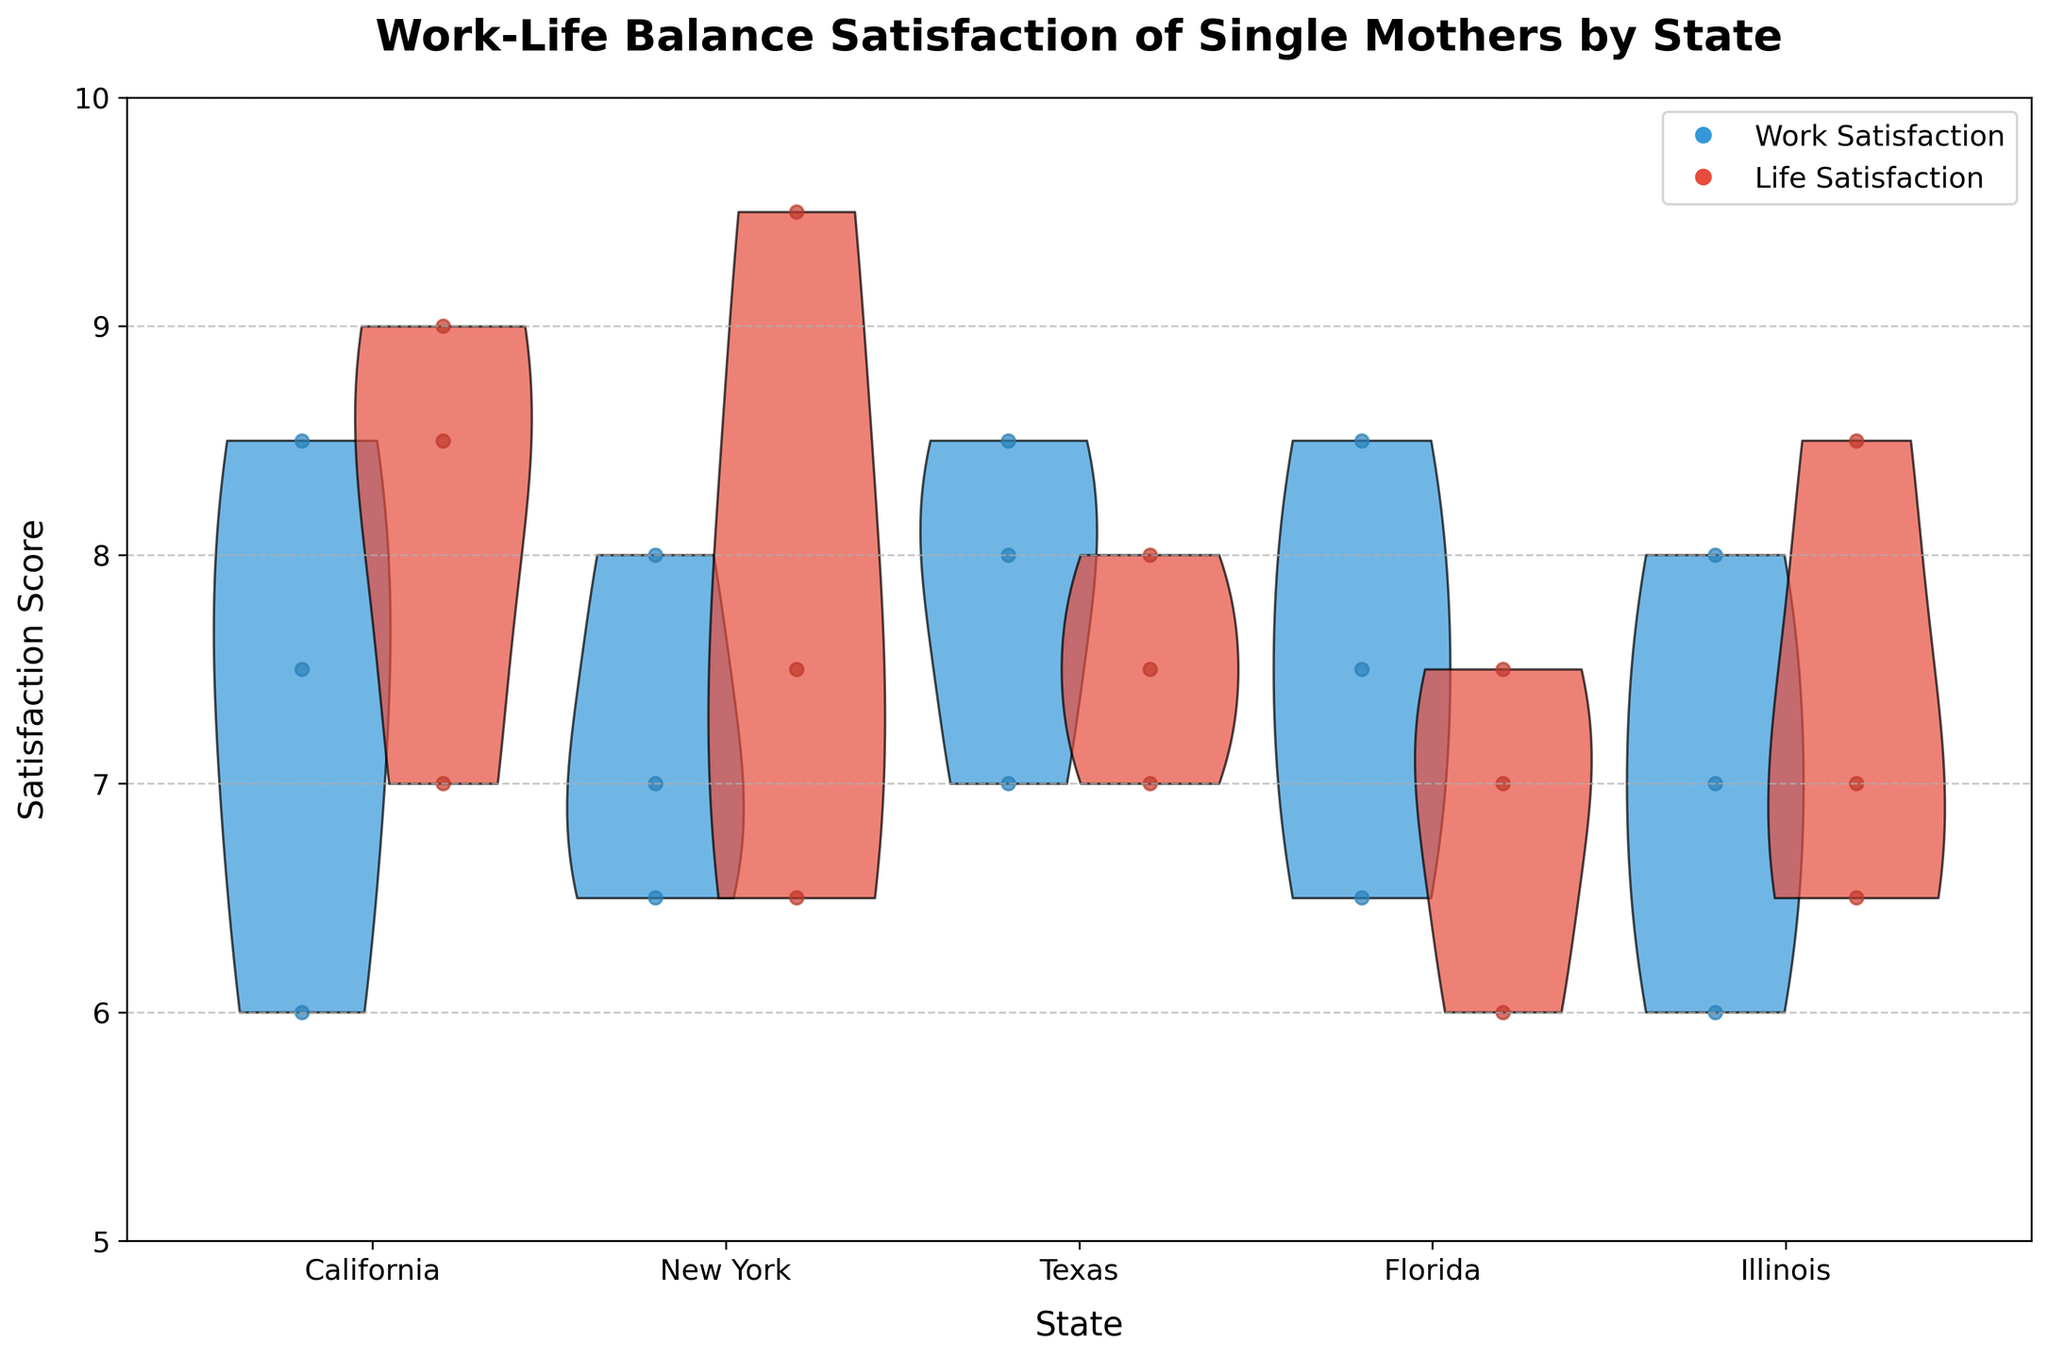what are the titles of this plot? Look at the top of the figure for the main title.
Answer: Work-Life Balance Satisfaction of Single Mothers by State What are the colors used to represent 'Work Satisfaction' and 'Life Satisfaction'? Refer to the legend located in the upper right corner for color identification. Work Satisfaction uses a shade of blue, and Life Satisfaction uses a shade of red.
Answer: Blue for Work Satisfaction, Red for Life Satisfaction Which state has the highest Work Satisfaction score? Observe the peak of the blue violin plots or the highest blue scatter points. In this case, Texas has the highest Work Satisfaction score around 8.5.
Answer: Texas What is the general trend in Life Satisfaction scores compared to Work Satisfaction scores across the states? Compare the positions and spreads of the red and blue violin plots and scatter points. Generally, red (Life Satisfaction) scores are slightly higher than blue (Work Satisfaction) scores in most states.
Answer: Life Satisfaction is slightly higher How does Illinois compare to California in terms of average Work Satisfaction? Look at the blue violin plots for both states and compare their central tendency or average height. California has slightly higher Work Satisfaction scores than Illinois.
Answer: California has higher Work Satisfaction than Illinois Which two states have the closest average scores in Work Satisfaction? Compare the central tendencies of the blue violin plots. Illinois and New York have similar Work Satisfaction scores.
Answer: Illinois and New York In which state is there the largest difference between Work Satisfaction and Life Satisfaction? Compare the distances between the peaks of the blue and red violin plots or the scatter points for each state. Florida shows the largest difference.
Answer: Florida Do any states show lower Life Satisfaction than Work Satisfaction? Observe the positions of the red and blue sections for each state. No state shows lower Life Satisfaction than Work Satisfaction; they are mostly equal or higher.
Answer: No What is the average Work Satisfaction score for New York? Sum the Work Satisfaction scores for New York and divide by the number of data points (7.0 + 6.5 + 8.0) / 3.
Answer: 7.17 How is the data distributed within the Work and Life Satisfaction scores for California? Examine the widths and positions of the blue and red violin plots for California. The Work scores are mostly clustered around the 7-8 range, while Life scores are around 7-9.
Answer: Work: 7-8 range, Life: 7-9 range 